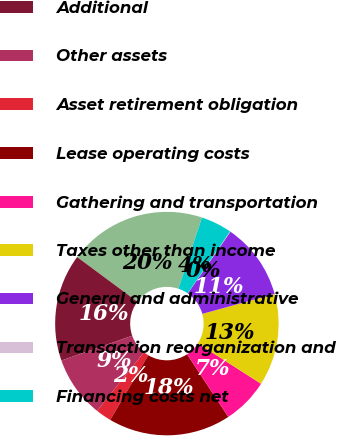Convert chart to OTSL. <chart><loc_0><loc_0><loc_500><loc_500><pie_chart><fcel>Recurring<fcel>Additional<fcel>Other assets<fcel>Asset retirement obligation<fcel>Lease operating costs<fcel>Gathering and transportation<fcel>Taxes other than income<fcel>General and administrative<fcel>Transaction reorganization and<fcel>Financing costs net<nl><fcel>19.93%<fcel>15.52%<fcel>8.9%<fcel>2.27%<fcel>17.73%<fcel>6.69%<fcel>13.31%<fcel>11.1%<fcel>0.07%<fcel>4.48%<nl></chart> 